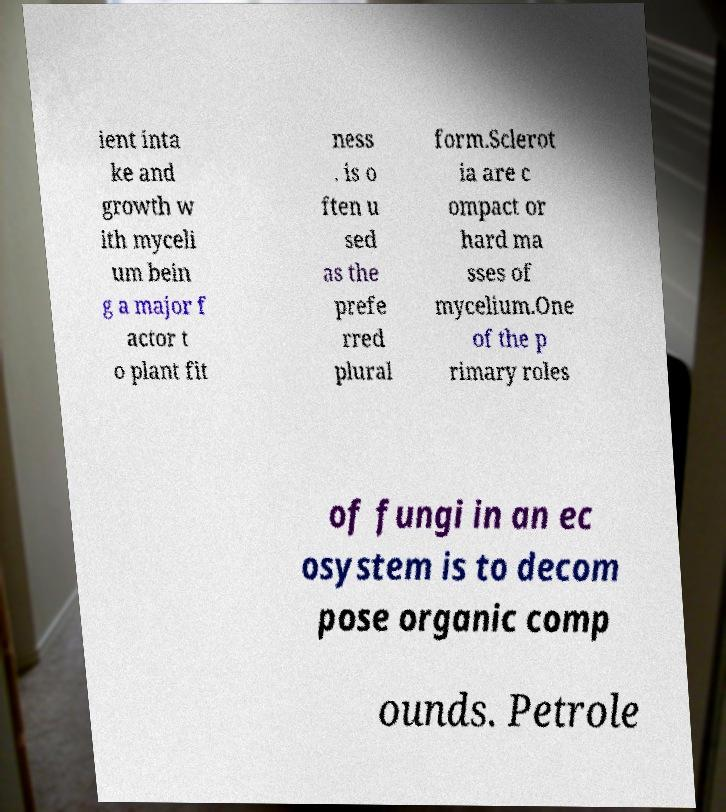Could you assist in decoding the text presented in this image and type it out clearly? ient inta ke and growth w ith myceli um bein g a major f actor t o plant fit ness . is o ften u sed as the prefe rred plural form.Sclerot ia are c ompact or hard ma sses of mycelium.One of the p rimary roles of fungi in an ec osystem is to decom pose organic comp ounds. Petrole 